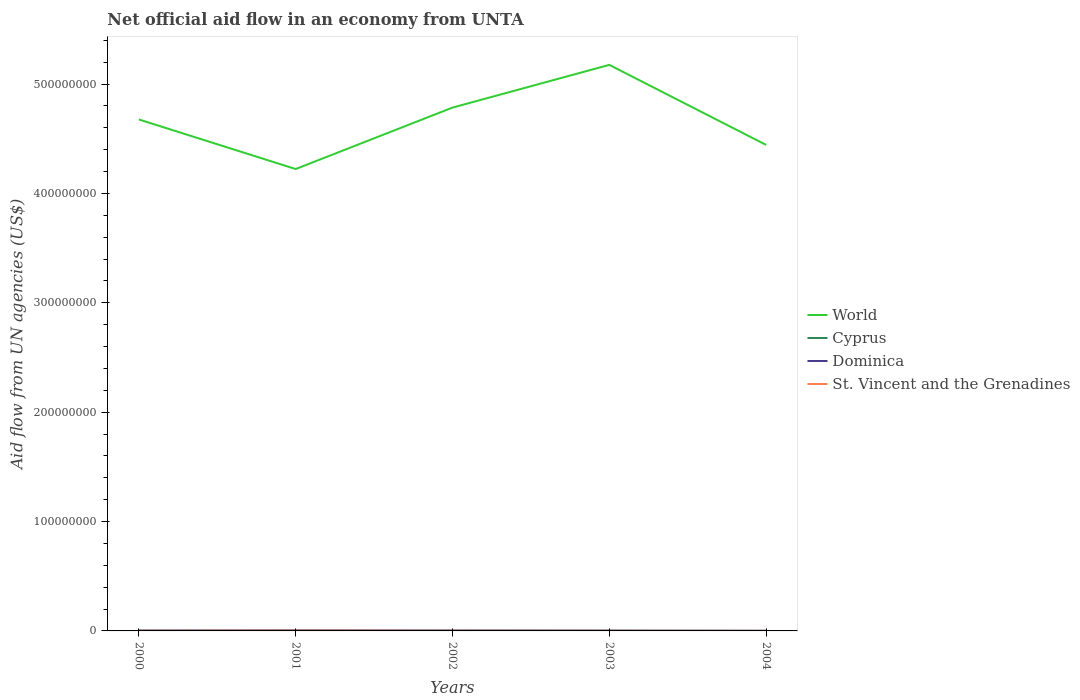Is the number of lines equal to the number of legend labels?
Your answer should be compact. Yes. Across all years, what is the maximum net official aid flow in Dominica?
Provide a short and direct response. 8.00e+04. In which year was the net official aid flow in Dominica maximum?
Give a very brief answer. 2004. What is the difference between the highest and the second highest net official aid flow in St. Vincent and the Grenadines?
Your answer should be compact. 2.20e+05. What is the difference between the highest and the lowest net official aid flow in Cyprus?
Make the answer very short. 1. What is the difference between two consecutive major ticks on the Y-axis?
Provide a short and direct response. 1.00e+08. Are the values on the major ticks of Y-axis written in scientific E-notation?
Provide a succinct answer. No. Does the graph contain any zero values?
Make the answer very short. No. Does the graph contain grids?
Make the answer very short. No. Where does the legend appear in the graph?
Provide a short and direct response. Center right. How are the legend labels stacked?
Provide a succinct answer. Vertical. What is the title of the graph?
Provide a short and direct response. Net official aid flow in an economy from UNTA. Does "Vietnam" appear as one of the legend labels in the graph?
Offer a very short reply. No. What is the label or title of the Y-axis?
Your answer should be compact. Aid flow from UN agencies (US$). What is the Aid flow from UN agencies (US$) in World in 2000?
Make the answer very short. 4.68e+08. What is the Aid flow from UN agencies (US$) of Cyprus in 2000?
Offer a very short reply. 1.70e+05. What is the Aid flow from UN agencies (US$) in Dominica in 2000?
Provide a short and direct response. 2.80e+05. What is the Aid flow from UN agencies (US$) of St. Vincent and the Grenadines in 2000?
Offer a terse response. 1.60e+05. What is the Aid flow from UN agencies (US$) in World in 2001?
Your answer should be very brief. 4.22e+08. What is the Aid flow from UN agencies (US$) in Cyprus in 2001?
Your answer should be very brief. 3.40e+05. What is the Aid flow from UN agencies (US$) of Dominica in 2001?
Provide a short and direct response. 3.80e+05. What is the Aid flow from UN agencies (US$) in World in 2002?
Keep it short and to the point. 4.78e+08. What is the Aid flow from UN agencies (US$) in Dominica in 2002?
Keep it short and to the point. 3.40e+05. What is the Aid flow from UN agencies (US$) of World in 2003?
Give a very brief answer. 5.18e+08. What is the Aid flow from UN agencies (US$) in Dominica in 2003?
Keep it short and to the point. 2.20e+05. What is the Aid flow from UN agencies (US$) in St. Vincent and the Grenadines in 2003?
Provide a succinct answer. 1.20e+05. What is the Aid flow from UN agencies (US$) in World in 2004?
Keep it short and to the point. 4.44e+08. What is the Aid flow from UN agencies (US$) of Cyprus in 2004?
Offer a terse response. 7.00e+04. What is the Aid flow from UN agencies (US$) in St. Vincent and the Grenadines in 2004?
Offer a terse response. 4.00e+04. Across all years, what is the maximum Aid flow from UN agencies (US$) of World?
Your response must be concise. 5.18e+08. Across all years, what is the maximum Aid flow from UN agencies (US$) of Cyprus?
Offer a terse response. 3.40e+05. Across all years, what is the maximum Aid flow from UN agencies (US$) of Dominica?
Keep it short and to the point. 3.80e+05. Across all years, what is the minimum Aid flow from UN agencies (US$) of World?
Provide a succinct answer. 4.22e+08. Across all years, what is the minimum Aid flow from UN agencies (US$) in Dominica?
Your answer should be compact. 8.00e+04. Across all years, what is the minimum Aid flow from UN agencies (US$) in St. Vincent and the Grenadines?
Keep it short and to the point. 4.00e+04. What is the total Aid flow from UN agencies (US$) in World in the graph?
Provide a succinct answer. 2.33e+09. What is the total Aid flow from UN agencies (US$) in Cyprus in the graph?
Your answer should be compact. 8.90e+05. What is the total Aid flow from UN agencies (US$) in Dominica in the graph?
Your answer should be very brief. 1.30e+06. What is the total Aid flow from UN agencies (US$) of St. Vincent and the Grenadines in the graph?
Your response must be concise. 7.40e+05. What is the difference between the Aid flow from UN agencies (US$) in World in 2000 and that in 2001?
Keep it short and to the point. 4.53e+07. What is the difference between the Aid flow from UN agencies (US$) in Cyprus in 2000 and that in 2001?
Ensure brevity in your answer.  -1.70e+05. What is the difference between the Aid flow from UN agencies (US$) in St. Vincent and the Grenadines in 2000 and that in 2001?
Offer a terse response. -1.00e+05. What is the difference between the Aid flow from UN agencies (US$) of World in 2000 and that in 2002?
Your answer should be compact. -1.08e+07. What is the difference between the Aid flow from UN agencies (US$) of Cyprus in 2000 and that in 2002?
Ensure brevity in your answer.  3.00e+04. What is the difference between the Aid flow from UN agencies (US$) in World in 2000 and that in 2003?
Give a very brief answer. -4.99e+07. What is the difference between the Aid flow from UN agencies (US$) of Cyprus in 2000 and that in 2003?
Provide a succinct answer. 0. What is the difference between the Aid flow from UN agencies (US$) of World in 2000 and that in 2004?
Offer a terse response. 2.33e+07. What is the difference between the Aid flow from UN agencies (US$) in World in 2001 and that in 2002?
Your answer should be compact. -5.62e+07. What is the difference between the Aid flow from UN agencies (US$) in Dominica in 2001 and that in 2002?
Give a very brief answer. 4.00e+04. What is the difference between the Aid flow from UN agencies (US$) in St. Vincent and the Grenadines in 2001 and that in 2002?
Your answer should be very brief. 1.00e+05. What is the difference between the Aid flow from UN agencies (US$) of World in 2001 and that in 2003?
Ensure brevity in your answer.  -9.52e+07. What is the difference between the Aid flow from UN agencies (US$) of Dominica in 2001 and that in 2003?
Your answer should be compact. 1.60e+05. What is the difference between the Aid flow from UN agencies (US$) in World in 2001 and that in 2004?
Provide a short and direct response. -2.20e+07. What is the difference between the Aid flow from UN agencies (US$) in Cyprus in 2001 and that in 2004?
Offer a very short reply. 2.70e+05. What is the difference between the Aid flow from UN agencies (US$) in Dominica in 2001 and that in 2004?
Offer a very short reply. 3.00e+05. What is the difference between the Aid flow from UN agencies (US$) of World in 2002 and that in 2003?
Keep it short and to the point. -3.91e+07. What is the difference between the Aid flow from UN agencies (US$) in Cyprus in 2002 and that in 2003?
Provide a succinct answer. -3.00e+04. What is the difference between the Aid flow from UN agencies (US$) in World in 2002 and that in 2004?
Provide a succinct answer. 3.41e+07. What is the difference between the Aid flow from UN agencies (US$) in St. Vincent and the Grenadines in 2002 and that in 2004?
Offer a very short reply. 1.20e+05. What is the difference between the Aid flow from UN agencies (US$) in World in 2003 and that in 2004?
Offer a terse response. 7.32e+07. What is the difference between the Aid flow from UN agencies (US$) of Cyprus in 2003 and that in 2004?
Give a very brief answer. 1.00e+05. What is the difference between the Aid flow from UN agencies (US$) in World in 2000 and the Aid flow from UN agencies (US$) in Cyprus in 2001?
Your response must be concise. 4.67e+08. What is the difference between the Aid flow from UN agencies (US$) in World in 2000 and the Aid flow from UN agencies (US$) in Dominica in 2001?
Your answer should be compact. 4.67e+08. What is the difference between the Aid flow from UN agencies (US$) in World in 2000 and the Aid flow from UN agencies (US$) in St. Vincent and the Grenadines in 2001?
Give a very brief answer. 4.67e+08. What is the difference between the Aid flow from UN agencies (US$) in Cyprus in 2000 and the Aid flow from UN agencies (US$) in Dominica in 2001?
Provide a short and direct response. -2.10e+05. What is the difference between the Aid flow from UN agencies (US$) in Cyprus in 2000 and the Aid flow from UN agencies (US$) in St. Vincent and the Grenadines in 2001?
Offer a terse response. -9.00e+04. What is the difference between the Aid flow from UN agencies (US$) in World in 2000 and the Aid flow from UN agencies (US$) in Cyprus in 2002?
Keep it short and to the point. 4.68e+08. What is the difference between the Aid flow from UN agencies (US$) in World in 2000 and the Aid flow from UN agencies (US$) in Dominica in 2002?
Make the answer very short. 4.67e+08. What is the difference between the Aid flow from UN agencies (US$) in World in 2000 and the Aid flow from UN agencies (US$) in St. Vincent and the Grenadines in 2002?
Offer a very short reply. 4.67e+08. What is the difference between the Aid flow from UN agencies (US$) in Cyprus in 2000 and the Aid flow from UN agencies (US$) in Dominica in 2002?
Provide a succinct answer. -1.70e+05. What is the difference between the Aid flow from UN agencies (US$) of Cyprus in 2000 and the Aid flow from UN agencies (US$) of St. Vincent and the Grenadines in 2002?
Make the answer very short. 10000. What is the difference between the Aid flow from UN agencies (US$) in Dominica in 2000 and the Aid flow from UN agencies (US$) in St. Vincent and the Grenadines in 2002?
Ensure brevity in your answer.  1.20e+05. What is the difference between the Aid flow from UN agencies (US$) of World in 2000 and the Aid flow from UN agencies (US$) of Cyprus in 2003?
Provide a succinct answer. 4.67e+08. What is the difference between the Aid flow from UN agencies (US$) in World in 2000 and the Aid flow from UN agencies (US$) in Dominica in 2003?
Give a very brief answer. 4.67e+08. What is the difference between the Aid flow from UN agencies (US$) in World in 2000 and the Aid flow from UN agencies (US$) in St. Vincent and the Grenadines in 2003?
Give a very brief answer. 4.68e+08. What is the difference between the Aid flow from UN agencies (US$) in Dominica in 2000 and the Aid flow from UN agencies (US$) in St. Vincent and the Grenadines in 2003?
Provide a succinct answer. 1.60e+05. What is the difference between the Aid flow from UN agencies (US$) in World in 2000 and the Aid flow from UN agencies (US$) in Cyprus in 2004?
Your answer should be compact. 4.68e+08. What is the difference between the Aid flow from UN agencies (US$) in World in 2000 and the Aid flow from UN agencies (US$) in Dominica in 2004?
Your answer should be very brief. 4.68e+08. What is the difference between the Aid flow from UN agencies (US$) of World in 2000 and the Aid flow from UN agencies (US$) of St. Vincent and the Grenadines in 2004?
Keep it short and to the point. 4.68e+08. What is the difference between the Aid flow from UN agencies (US$) in Cyprus in 2000 and the Aid flow from UN agencies (US$) in St. Vincent and the Grenadines in 2004?
Offer a very short reply. 1.30e+05. What is the difference between the Aid flow from UN agencies (US$) in World in 2001 and the Aid flow from UN agencies (US$) in Cyprus in 2002?
Offer a terse response. 4.22e+08. What is the difference between the Aid flow from UN agencies (US$) in World in 2001 and the Aid flow from UN agencies (US$) in Dominica in 2002?
Your answer should be very brief. 4.22e+08. What is the difference between the Aid flow from UN agencies (US$) of World in 2001 and the Aid flow from UN agencies (US$) of St. Vincent and the Grenadines in 2002?
Offer a very short reply. 4.22e+08. What is the difference between the Aid flow from UN agencies (US$) of Cyprus in 2001 and the Aid flow from UN agencies (US$) of Dominica in 2002?
Your response must be concise. 0. What is the difference between the Aid flow from UN agencies (US$) in Cyprus in 2001 and the Aid flow from UN agencies (US$) in St. Vincent and the Grenadines in 2002?
Give a very brief answer. 1.80e+05. What is the difference between the Aid flow from UN agencies (US$) of Dominica in 2001 and the Aid flow from UN agencies (US$) of St. Vincent and the Grenadines in 2002?
Your answer should be very brief. 2.20e+05. What is the difference between the Aid flow from UN agencies (US$) of World in 2001 and the Aid flow from UN agencies (US$) of Cyprus in 2003?
Your answer should be compact. 4.22e+08. What is the difference between the Aid flow from UN agencies (US$) in World in 2001 and the Aid flow from UN agencies (US$) in Dominica in 2003?
Your response must be concise. 4.22e+08. What is the difference between the Aid flow from UN agencies (US$) of World in 2001 and the Aid flow from UN agencies (US$) of St. Vincent and the Grenadines in 2003?
Your answer should be very brief. 4.22e+08. What is the difference between the Aid flow from UN agencies (US$) in Cyprus in 2001 and the Aid flow from UN agencies (US$) in St. Vincent and the Grenadines in 2003?
Offer a terse response. 2.20e+05. What is the difference between the Aid flow from UN agencies (US$) in Dominica in 2001 and the Aid flow from UN agencies (US$) in St. Vincent and the Grenadines in 2003?
Ensure brevity in your answer.  2.60e+05. What is the difference between the Aid flow from UN agencies (US$) of World in 2001 and the Aid flow from UN agencies (US$) of Cyprus in 2004?
Your answer should be very brief. 4.22e+08. What is the difference between the Aid flow from UN agencies (US$) in World in 2001 and the Aid flow from UN agencies (US$) in Dominica in 2004?
Make the answer very short. 4.22e+08. What is the difference between the Aid flow from UN agencies (US$) of World in 2001 and the Aid flow from UN agencies (US$) of St. Vincent and the Grenadines in 2004?
Provide a short and direct response. 4.22e+08. What is the difference between the Aid flow from UN agencies (US$) in Cyprus in 2001 and the Aid flow from UN agencies (US$) in Dominica in 2004?
Give a very brief answer. 2.60e+05. What is the difference between the Aid flow from UN agencies (US$) in Dominica in 2001 and the Aid flow from UN agencies (US$) in St. Vincent and the Grenadines in 2004?
Provide a succinct answer. 3.40e+05. What is the difference between the Aid flow from UN agencies (US$) in World in 2002 and the Aid flow from UN agencies (US$) in Cyprus in 2003?
Provide a succinct answer. 4.78e+08. What is the difference between the Aid flow from UN agencies (US$) of World in 2002 and the Aid flow from UN agencies (US$) of Dominica in 2003?
Ensure brevity in your answer.  4.78e+08. What is the difference between the Aid flow from UN agencies (US$) in World in 2002 and the Aid flow from UN agencies (US$) in St. Vincent and the Grenadines in 2003?
Provide a succinct answer. 4.78e+08. What is the difference between the Aid flow from UN agencies (US$) of Cyprus in 2002 and the Aid flow from UN agencies (US$) of Dominica in 2003?
Keep it short and to the point. -8.00e+04. What is the difference between the Aid flow from UN agencies (US$) of Cyprus in 2002 and the Aid flow from UN agencies (US$) of St. Vincent and the Grenadines in 2003?
Provide a succinct answer. 2.00e+04. What is the difference between the Aid flow from UN agencies (US$) in World in 2002 and the Aid flow from UN agencies (US$) in Cyprus in 2004?
Keep it short and to the point. 4.78e+08. What is the difference between the Aid flow from UN agencies (US$) of World in 2002 and the Aid flow from UN agencies (US$) of Dominica in 2004?
Your answer should be compact. 4.78e+08. What is the difference between the Aid flow from UN agencies (US$) in World in 2002 and the Aid flow from UN agencies (US$) in St. Vincent and the Grenadines in 2004?
Ensure brevity in your answer.  4.78e+08. What is the difference between the Aid flow from UN agencies (US$) of Cyprus in 2002 and the Aid flow from UN agencies (US$) of St. Vincent and the Grenadines in 2004?
Provide a succinct answer. 1.00e+05. What is the difference between the Aid flow from UN agencies (US$) in Dominica in 2002 and the Aid flow from UN agencies (US$) in St. Vincent and the Grenadines in 2004?
Ensure brevity in your answer.  3.00e+05. What is the difference between the Aid flow from UN agencies (US$) of World in 2003 and the Aid flow from UN agencies (US$) of Cyprus in 2004?
Offer a very short reply. 5.17e+08. What is the difference between the Aid flow from UN agencies (US$) of World in 2003 and the Aid flow from UN agencies (US$) of Dominica in 2004?
Ensure brevity in your answer.  5.17e+08. What is the difference between the Aid flow from UN agencies (US$) in World in 2003 and the Aid flow from UN agencies (US$) in St. Vincent and the Grenadines in 2004?
Provide a succinct answer. 5.18e+08. What is the difference between the Aid flow from UN agencies (US$) of Cyprus in 2003 and the Aid flow from UN agencies (US$) of St. Vincent and the Grenadines in 2004?
Your answer should be very brief. 1.30e+05. What is the difference between the Aid flow from UN agencies (US$) of Dominica in 2003 and the Aid flow from UN agencies (US$) of St. Vincent and the Grenadines in 2004?
Provide a succinct answer. 1.80e+05. What is the average Aid flow from UN agencies (US$) in World per year?
Your answer should be very brief. 4.66e+08. What is the average Aid flow from UN agencies (US$) of Cyprus per year?
Keep it short and to the point. 1.78e+05. What is the average Aid flow from UN agencies (US$) in St. Vincent and the Grenadines per year?
Give a very brief answer. 1.48e+05. In the year 2000, what is the difference between the Aid flow from UN agencies (US$) of World and Aid flow from UN agencies (US$) of Cyprus?
Make the answer very short. 4.67e+08. In the year 2000, what is the difference between the Aid flow from UN agencies (US$) of World and Aid flow from UN agencies (US$) of Dominica?
Offer a terse response. 4.67e+08. In the year 2000, what is the difference between the Aid flow from UN agencies (US$) in World and Aid flow from UN agencies (US$) in St. Vincent and the Grenadines?
Your response must be concise. 4.67e+08. In the year 2000, what is the difference between the Aid flow from UN agencies (US$) of Cyprus and Aid flow from UN agencies (US$) of Dominica?
Your answer should be compact. -1.10e+05. In the year 2001, what is the difference between the Aid flow from UN agencies (US$) of World and Aid flow from UN agencies (US$) of Cyprus?
Offer a very short reply. 4.22e+08. In the year 2001, what is the difference between the Aid flow from UN agencies (US$) of World and Aid flow from UN agencies (US$) of Dominica?
Your answer should be compact. 4.22e+08. In the year 2001, what is the difference between the Aid flow from UN agencies (US$) of World and Aid flow from UN agencies (US$) of St. Vincent and the Grenadines?
Keep it short and to the point. 4.22e+08. In the year 2001, what is the difference between the Aid flow from UN agencies (US$) in Cyprus and Aid flow from UN agencies (US$) in Dominica?
Offer a very short reply. -4.00e+04. In the year 2002, what is the difference between the Aid flow from UN agencies (US$) in World and Aid flow from UN agencies (US$) in Cyprus?
Ensure brevity in your answer.  4.78e+08. In the year 2002, what is the difference between the Aid flow from UN agencies (US$) in World and Aid flow from UN agencies (US$) in Dominica?
Keep it short and to the point. 4.78e+08. In the year 2002, what is the difference between the Aid flow from UN agencies (US$) in World and Aid flow from UN agencies (US$) in St. Vincent and the Grenadines?
Make the answer very short. 4.78e+08. In the year 2003, what is the difference between the Aid flow from UN agencies (US$) of World and Aid flow from UN agencies (US$) of Cyprus?
Ensure brevity in your answer.  5.17e+08. In the year 2003, what is the difference between the Aid flow from UN agencies (US$) in World and Aid flow from UN agencies (US$) in Dominica?
Make the answer very short. 5.17e+08. In the year 2003, what is the difference between the Aid flow from UN agencies (US$) in World and Aid flow from UN agencies (US$) in St. Vincent and the Grenadines?
Keep it short and to the point. 5.17e+08. In the year 2003, what is the difference between the Aid flow from UN agencies (US$) of Cyprus and Aid flow from UN agencies (US$) of St. Vincent and the Grenadines?
Your answer should be very brief. 5.00e+04. In the year 2004, what is the difference between the Aid flow from UN agencies (US$) of World and Aid flow from UN agencies (US$) of Cyprus?
Your answer should be compact. 4.44e+08. In the year 2004, what is the difference between the Aid flow from UN agencies (US$) of World and Aid flow from UN agencies (US$) of Dominica?
Your response must be concise. 4.44e+08. In the year 2004, what is the difference between the Aid flow from UN agencies (US$) in World and Aid flow from UN agencies (US$) in St. Vincent and the Grenadines?
Your answer should be very brief. 4.44e+08. In the year 2004, what is the difference between the Aid flow from UN agencies (US$) of Cyprus and Aid flow from UN agencies (US$) of Dominica?
Offer a very short reply. -10000. In the year 2004, what is the difference between the Aid flow from UN agencies (US$) of Dominica and Aid flow from UN agencies (US$) of St. Vincent and the Grenadines?
Provide a succinct answer. 4.00e+04. What is the ratio of the Aid flow from UN agencies (US$) in World in 2000 to that in 2001?
Offer a terse response. 1.11. What is the ratio of the Aid flow from UN agencies (US$) in Cyprus in 2000 to that in 2001?
Ensure brevity in your answer.  0.5. What is the ratio of the Aid flow from UN agencies (US$) of Dominica in 2000 to that in 2001?
Offer a terse response. 0.74. What is the ratio of the Aid flow from UN agencies (US$) in St. Vincent and the Grenadines in 2000 to that in 2001?
Keep it short and to the point. 0.62. What is the ratio of the Aid flow from UN agencies (US$) in World in 2000 to that in 2002?
Offer a very short reply. 0.98. What is the ratio of the Aid flow from UN agencies (US$) of Cyprus in 2000 to that in 2002?
Your answer should be very brief. 1.21. What is the ratio of the Aid flow from UN agencies (US$) in Dominica in 2000 to that in 2002?
Provide a short and direct response. 0.82. What is the ratio of the Aid flow from UN agencies (US$) in St. Vincent and the Grenadines in 2000 to that in 2002?
Offer a very short reply. 1. What is the ratio of the Aid flow from UN agencies (US$) in World in 2000 to that in 2003?
Offer a very short reply. 0.9. What is the ratio of the Aid flow from UN agencies (US$) of Dominica in 2000 to that in 2003?
Offer a very short reply. 1.27. What is the ratio of the Aid flow from UN agencies (US$) of St. Vincent and the Grenadines in 2000 to that in 2003?
Your response must be concise. 1.33. What is the ratio of the Aid flow from UN agencies (US$) of World in 2000 to that in 2004?
Offer a very short reply. 1.05. What is the ratio of the Aid flow from UN agencies (US$) in Cyprus in 2000 to that in 2004?
Provide a succinct answer. 2.43. What is the ratio of the Aid flow from UN agencies (US$) in World in 2001 to that in 2002?
Your response must be concise. 0.88. What is the ratio of the Aid flow from UN agencies (US$) in Cyprus in 2001 to that in 2002?
Your answer should be very brief. 2.43. What is the ratio of the Aid flow from UN agencies (US$) in Dominica in 2001 to that in 2002?
Offer a terse response. 1.12. What is the ratio of the Aid flow from UN agencies (US$) of St. Vincent and the Grenadines in 2001 to that in 2002?
Offer a very short reply. 1.62. What is the ratio of the Aid flow from UN agencies (US$) of World in 2001 to that in 2003?
Provide a short and direct response. 0.82. What is the ratio of the Aid flow from UN agencies (US$) of Dominica in 2001 to that in 2003?
Provide a short and direct response. 1.73. What is the ratio of the Aid flow from UN agencies (US$) in St. Vincent and the Grenadines in 2001 to that in 2003?
Your answer should be very brief. 2.17. What is the ratio of the Aid flow from UN agencies (US$) of World in 2001 to that in 2004?
Your answer should be very brief. 0.95. What is the ratio of the Aid flow from UN agencies (US$) of Cyprus in 2001 to that in 2004?
Keep it short and to the point. 4.86. What is the ratio of the Aid flow from UN agencies (US$) of Dominica in 2001 to that in 2004?
Provide a succinct answer. 4.75. What is the ratio of the Aid flow from UN agencies (US$) of St. Vincent and the Grenadines in 2001 to that in 2004?
Offer a terse response. 6.5. What is the ratio of the Aid flow from UN agencies (US$) of World in 2002 to that in 2003?
Keep it short and to the point. 0.92. What is the ratio of the Aid flow from UN agencies (US$) in Cyprus in 2002 to that in 2003?
Your answer should be compact. 0.82. What is the ratio of the Aid flow from UN agencies (US$) of Dominica in 2002 to that in 2003?
Keep it short and to the point. 1.55. What is the ratio of the Aid flow from UN agencies (US$) in St. Vincent and the Grenadines in 2002 to that in 2003?
Provide a short and direct response. 1.33. What is the ratio of the Aid flow from UN agencies (US$) in World in 2002 to that in 2004?
Provide a short and direct response. 1.08. What is the ratio of the Aid flow from UN agencies (US$) of Cyprus in 2002 to that in 2004?
Your answer should be very brief. 2. What is the ratio of the Aid flow from UN agencies (US$) of Dominica in 2002 to that in 2004?
Provide a succinct answer. 4.25. What is the ratio of the Aid flow from UN agencies (US$) of St. Vincent and the Grenadines in 2002 to that in 2004?
Ensure brevity in your answer.  4. What is the ratio of the Aid flow from UN agencies (US$) of World in 2003 to that in 2004?
Make the answer very short. 1.16. What is the ratio of the Aid flow from UN agencies (US$) in Cyprus in 2003 to that in 2004?
Ensure brevity in your answer.  2.43. What is the ratio of the Aid flow from UN agencies (US$) of Dominica in 2003 to that in 2004?
Ensure brevity in your answer.  2.75. What is the difference between the highest and the second highest Aid flow from UN agencies (US$) in World?
Make the answer very short. 3.91e+07. What is the difference between the highest and the second highest Aid flow from UN agencies (US$) of St. Vincent and the Grenadines?
Offer a very short reply. 1.00e+05. What is the difference between the highest and the lowest Aid flow from UN agencies (US$) of World?
Offer a terse response. 9.52e+07. What is the difference between the highest and the lowest Aid flow from UN agencies (US$) of Dominica?
Keep it short and to the point. 3.00e+05. What is the difference between the highest and the lowest Aid flow from UN agencies (US$) in St. Vincent and the Grenadines?
Give a very brief answer. 2.20e+05. 